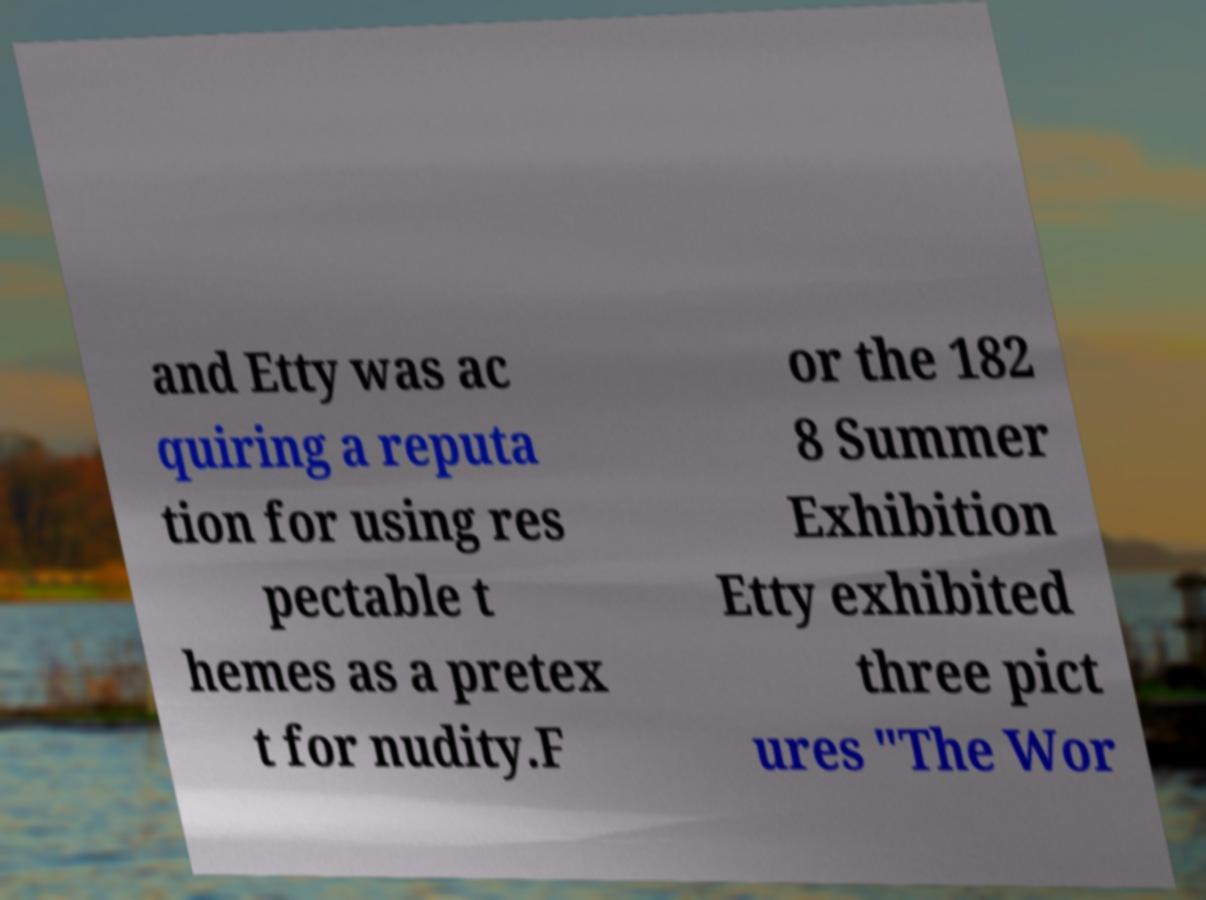Please identify and transcribe the text found in this image. and Etty was ac quiring a reputa tion for using res pectable t hemes as a pretex t for nudity.F or the 182 8 Summer Exhibition Etty exhibited three pict ures "The Wor 